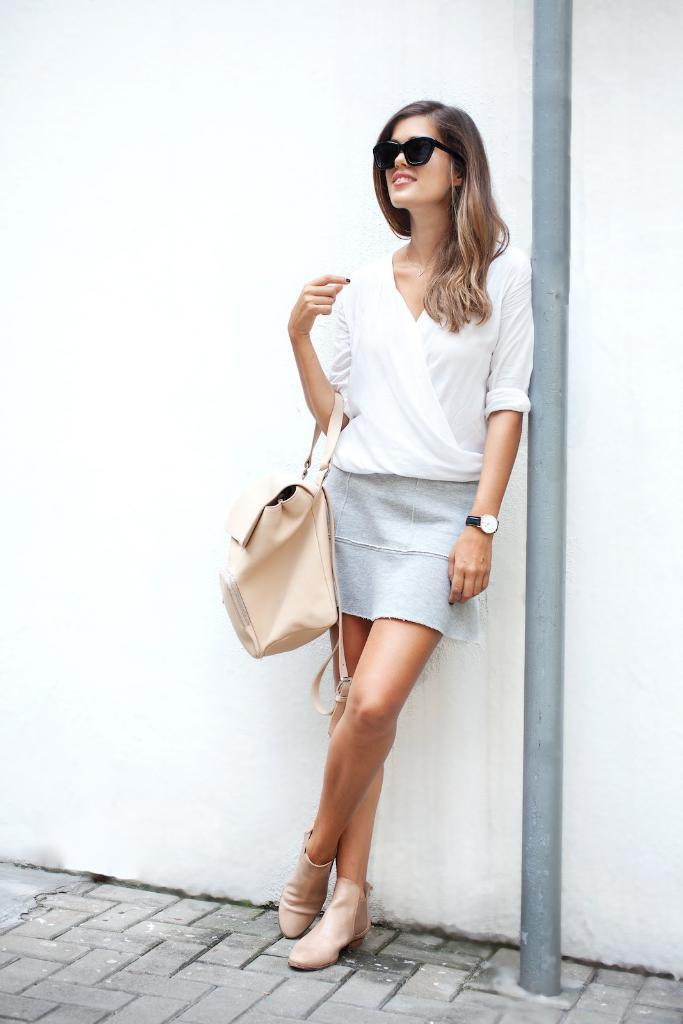Who is present in the image? There is a woman in the image. What is the woman doing in the image? The woman is leaning on a wall. What is the woman wearing in the image? The woman is wearing spectacles. What is the woman carrying in the image? The woman is carrying a bag. What other object can be seen in the image? There is a pole in the image. How many ants are crawling on the woman's bag in the image? There are no ants present in the image, so it is not possible to determine how many might be crawling on the bag. 